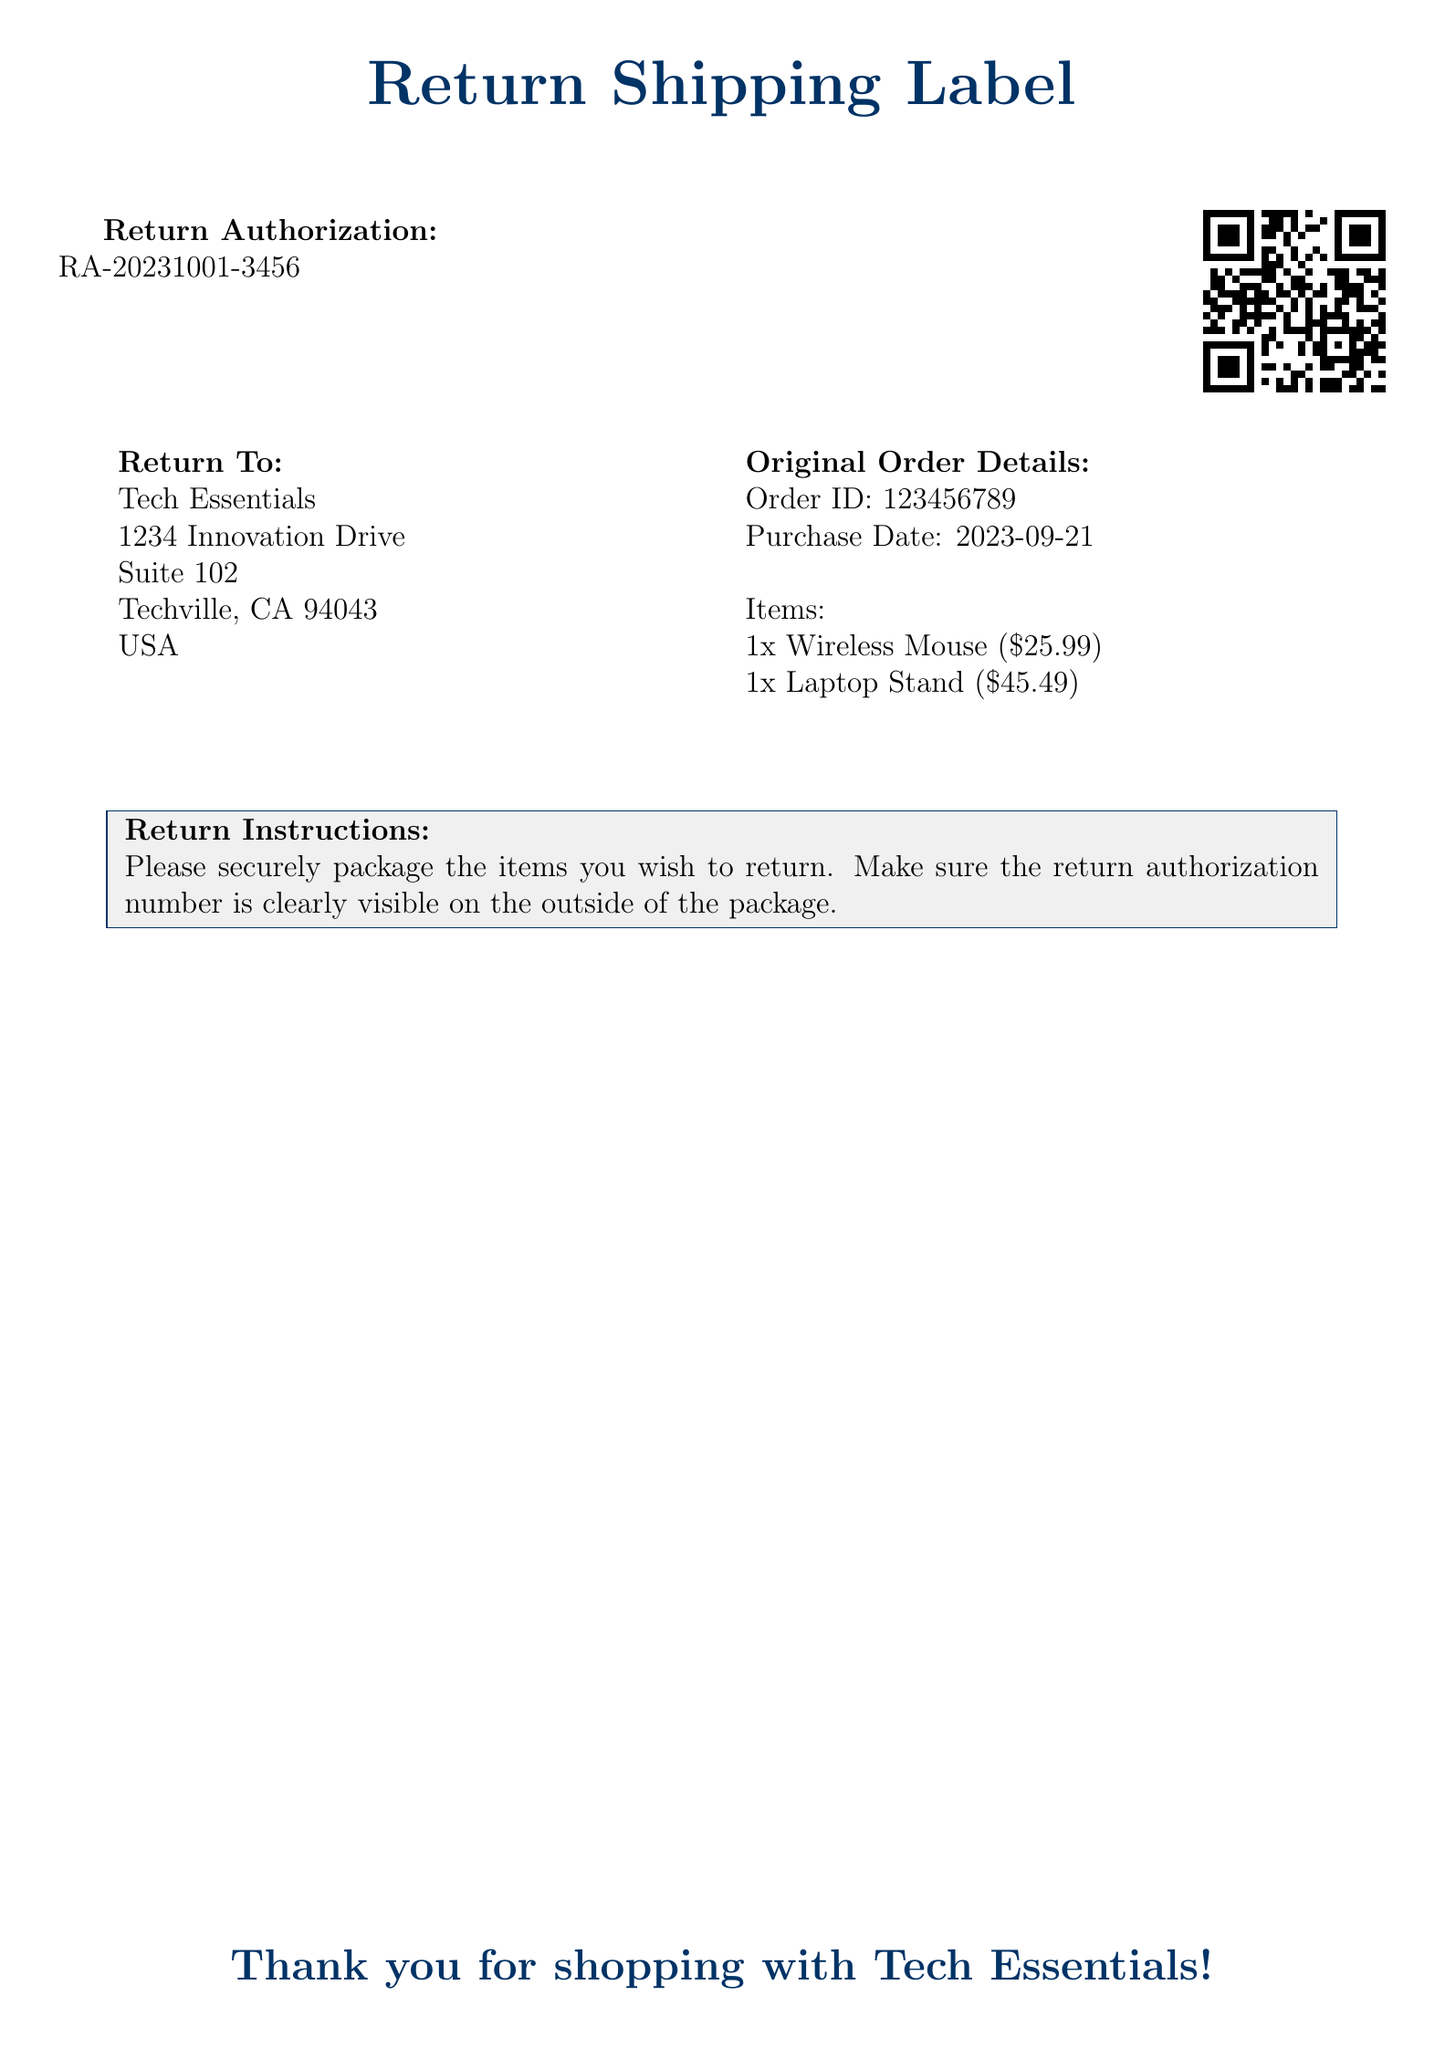What is the return authorization number? The return authorization number is listed at the top of the document under "Return Authorization."
Answer: RA-20231001-3456 What is the order ID? The order ID is provided in the section detailing the original order.
Answer: 123456789 When was the purchase made? The purchase date is specified in the original order details section.
Answer: 2023-09-21 How many items are being returned? The items section lists the quantities of each item being returned.
Answer: 2 What is the first item being returned? The document lists items in the original order details, the first item is mentioned at the start.
Answer: Wireless Mouse What is the return address? The return address is included at the top of the return details section.
Answer: Tech Essentials, 1234 Innovation Drive, Suite 102, Techville, CA 94043, USA What is included in the return instructions? The return instructions section suggests what to do with the items being returned.
Answer: Securely package the items What is the total cost of the items being returned? The cost of returned items is the sum of individual item prices listed in the document.
Answer: $71.48 What is the last line of the document? The last line expresses gratitude to the customer for their purchase.
Answer: Thank you for shopping with Tech Essentials! 